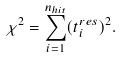Convert formula to latex. <formula><loc_0><loc_0><loc_500><loc_500>\chi ^ { 2 } = \sum _ { i = 1 } ^ { n _ { h i t } } ( { t ^ { r e s } _ { i } } ) ^ { 2 } .</formula> 